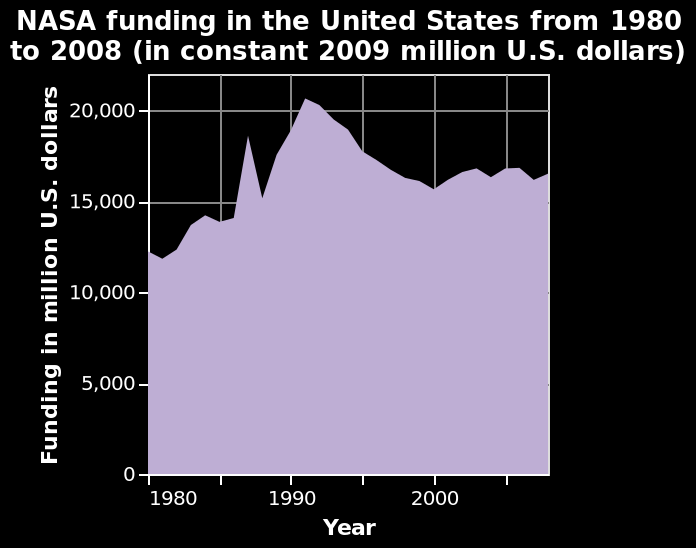<image>
Describe the following image in detail Here a area diagram is titled NASA funding in the United States from 1980 to 2008 (in constant 2009 million U.S. dollars). On the y-axis, Funding in million U.S. dollars is measured. On the x-axis, Year is shown. 